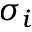Convert formula to latex. <formula><loc_0><loc_0><loc_500><loc_500>\sigma _ { i }</formula> 